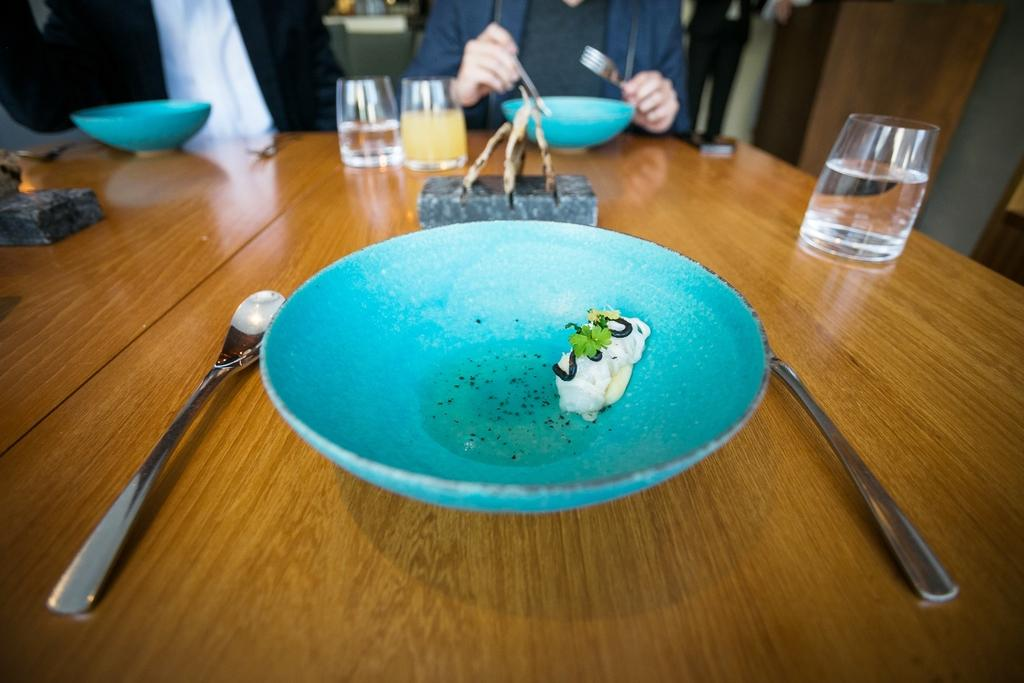What is the main piece of furniture in the image? There is a table in the image. What is on the table? The table has plates with food on it, glasses, and spoons. Can you describe the people in the background of the image? There are two people in the background of the image, and one of them is wearing a blue jacket. What is the person with the blue jacket holding? The person with the blue jacket is holding a spoon. What type of battle is taking place in the image? There is no battle present in the image; it features a table with food and utensils, as well as two people in the background. Can you describe the activity involving horses in the image? There are no horses or any related activity present in the image. 